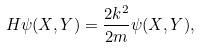<formula> <loc_0><loc_0><loc_500><loc_500>H \psi ( X , Y ) = \frac { { 2 } k ^ { 2 } } { 2 m } \psi ( X , Y ) ,</formula> 